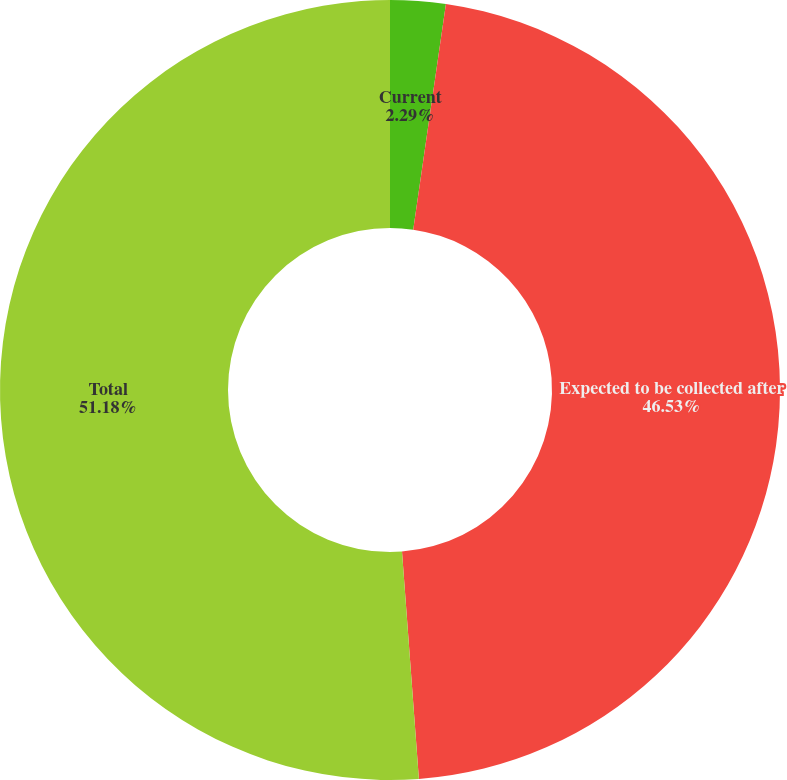Convert chart. <chart><loc_0><loc_0><loc_500><loc_500><pie_chart><fcel>Current<fcel>Expected to be collected after<fcel>Total<nl><fcel>2.29%<fcel>46.53%<fcel>51.18%<nl></chart> 